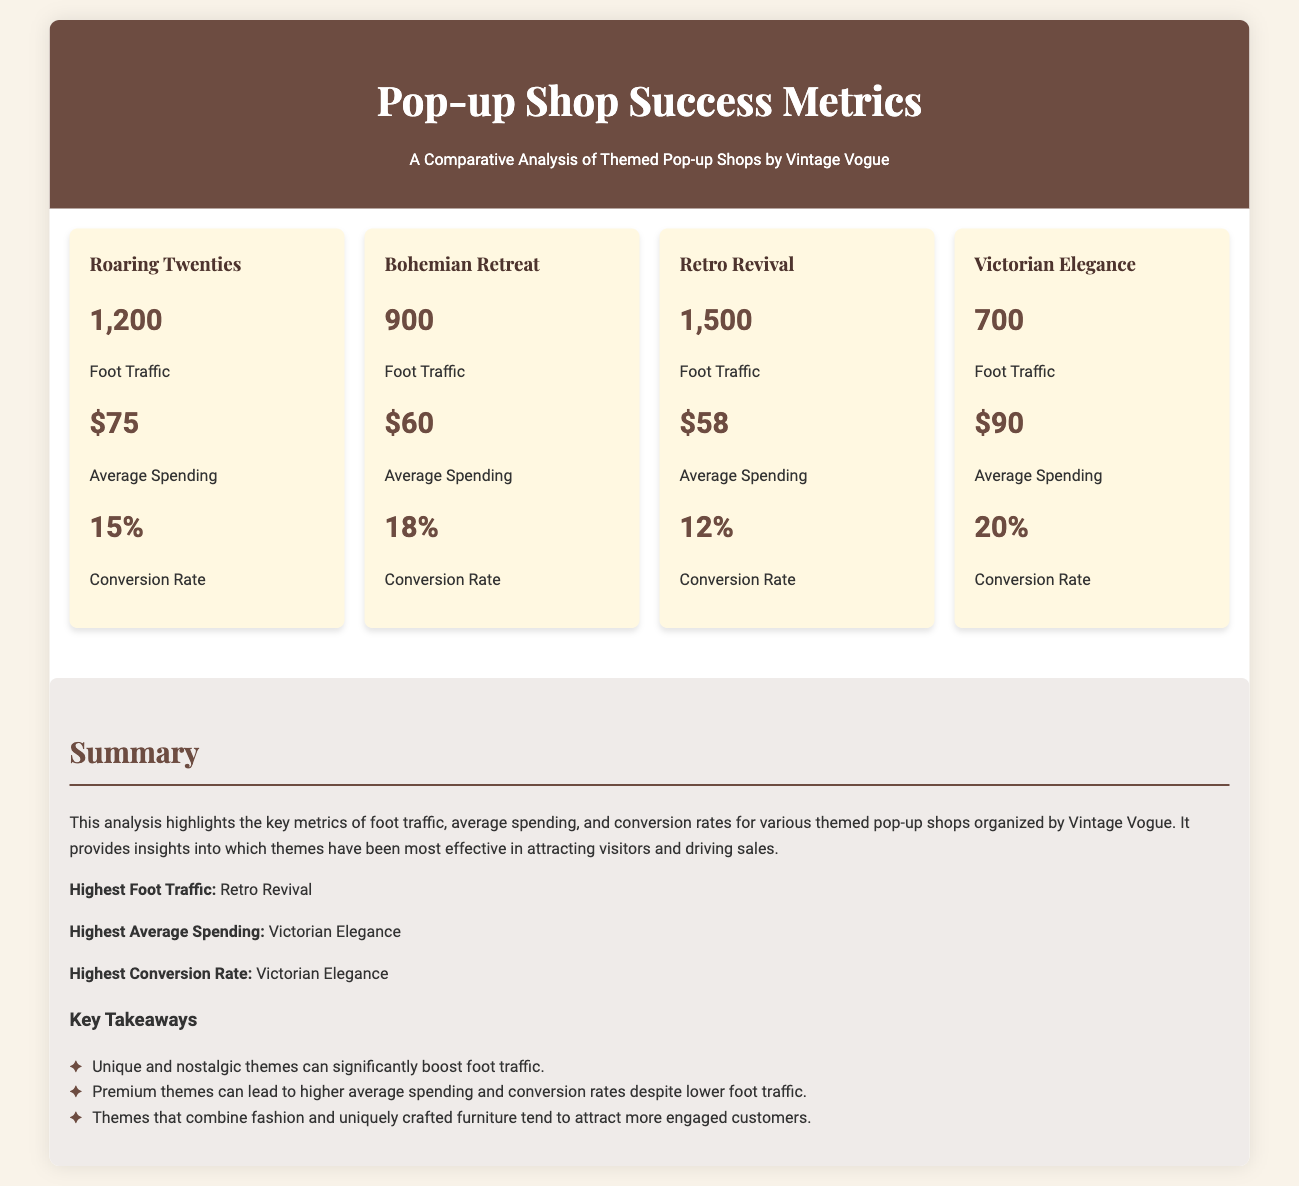What is the foot traffic for the Roaring Twenties theme? The foot traffic for the Roaring Twenties theme is given in the metrics grid, which is 1,200.
Answer: 1,200 What is the average spending for the Bohemian Retreat? The average spending for the Bohemian Retreat is listed in the document, which is $60.
Answer: $60 Which theme has the highest conversion rate? To determine the highest conversion rate, one can compare the conversion rates displayed for each theme. The highest is 20% for the Victorian Elegance.
Answer: Victorian Elegance What was the foot traffic for the Retro Revival theme? The foot traffic for the Retro Revival theme can be found in the metrics grid, which specifies that it is 1,500.
Answer: 1,500 Which themed pop-up shop had the least foot traffic? By comparing the foot traffic numbers, the least foot traffic can be identified as 700 for Victorian Elegance.
Answer: Victorian Elegance What is the average spending for the Victorian Elegance? The average spending for the Victorian Elegance is provided in the data, which shows it as $90.
Answer: $90 Which theme combined fashion and furniture? The summary suggests a combination of fashion and uniquely crafted furniture, which tends to attract more engaged customers; all themes do so, but specific mentions are not made.
Answer: All themes What is the average spending for the theme with the highest foot traffic? The document specifies the average spending for Retro Revival, which has the highest foot traffic at $58.
Answer: $58 How many total themes are listed in the document? The total number of themes can be counted from the metric cards, showing there are four.
Answer: Four 